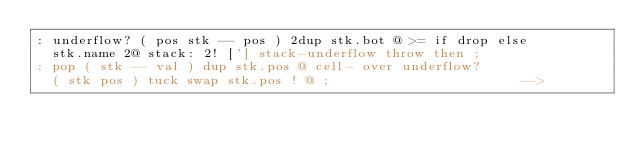Convert code to text. <code><loc_0><loc_0><loc_500><loc_500><_Forth_>: underflow? ( pos stk -- pos ) 2dup stk.bot @ >= if drop else
  stk.name 2@ stack: 2! ['] stack-underflow throw then ;
: pop ( stk -- val ) dup stk.pos @ cell- over underflow?
  ( stk pos ) tuck swap stk.pos ! @ ;                        -->
</code> 